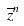Convert formula to latex. <formula><loc_0><loc_0><loc_500><loc_500>\overline { z } ^ { n }</formula> 